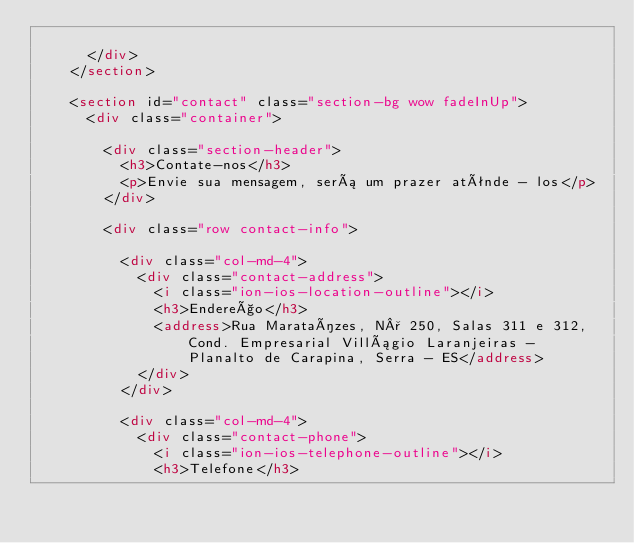Convert code to text. <code><loc_0><loc_0><loc_500><loc_500><_HTML_>        
      </div>
    </section>

    <section id="contact" class="section-bg wow fadeInUp">
      <div class="container">

        <div class="section-header">
          <h3>Contate-nos</h3>
          <p>Envie sua mensagem, será um prazer atênde - los</p>
        </div>

        <div class="row contact-info">

          <div class="col-md-4">
            <div class="contact-address">
              <i class="ion-ios-location-outline"></i>
              <h3>Endereço</h3>
              <address>Rua Marataízes, N° 250, Salas 311 e 312, Cond. Empresarial Villágio Laranjeiras - Planalto de Carapina, Serra - ES</address>
            </div>
          </div>

          <div class="col-md-4">
            <div class="contact-phone">
              <i class="ion-ios-telephone-outline"></i>
              <h3>Telefone</h3></code> 